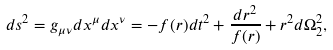<formula> <loc_0><loc_0><loc_500><loc_500>d s ^ { 2 } = g _ { \mu \nu } d x ^ { \mu } d x ^ { \nu } = - f ( r ) d t ^ { 2 } + \frac { d r ^ { 2 } } { f ( r ) } + r ^ { 2 } d \Omega _ { 2 } ^ { 2 } ,</formula> 